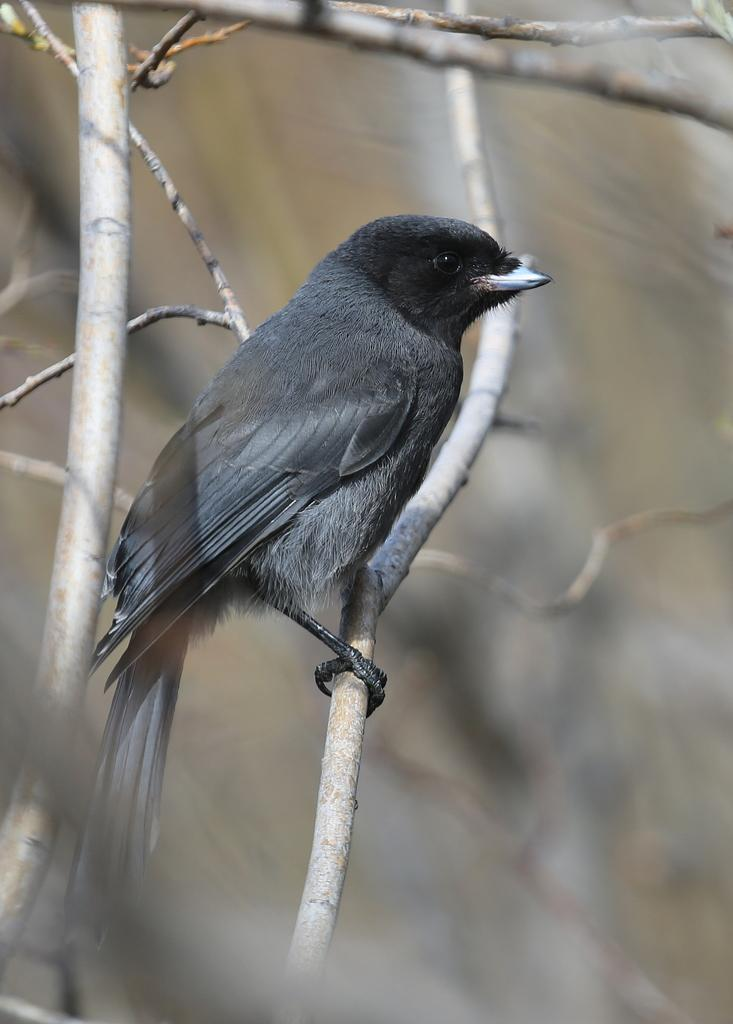What type of animal can be seen in the image? There is a bird in the image. Where is the bird located in the image? The bird is on a stem in the image. What can be observed about the background of the image? The background of the image is blurred. What else can be seen in the image besides the bird? There are stems in the image. What type of act is the band performing in the image? There is no band or act present in the image; it features a bird on a stem with blurred background and stems. 